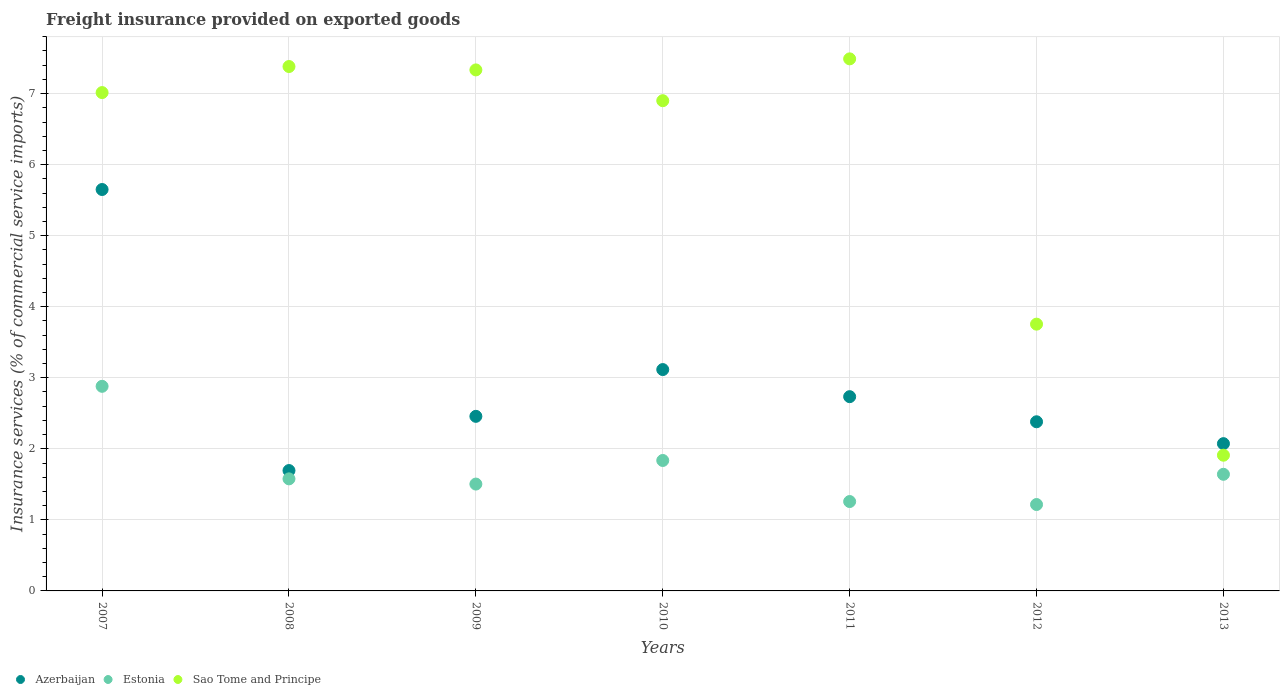How many different coloured dotlines are there?
Your answer should be compact. 3. What is the freight insurance provided on exported goods in Sao Tome and Principe in 2007?
Your answer should be compact. 7.01. Across all years, what is the maximum freight insurance provided on exported goods in Sao Tome and Principe?
Offer a terse response. 7.49. Across all years, what is the minimum freight insurance provided on exported goods in Azerbaijan?
Make the answer very short. 1.69. In which year was the freight insurance provided on exported goods in Azerbaijan maximum?
Provide a short and direct response. 2007. What is the total freight insurance provided on exported goods in Estonia in the graph?
Offer a very short reply. 11.91. What is the difference between the freight insurance provided on exported goods in Estonia in 2008 and that in 2011?
Provide a short and direct response. 0.32. What is the difference between the freight insurance provided on exported goods in Sao Tome and Principe in 2008 and the freight insurance provided on exported goods in Azerbaijan in 2007?
Keep it short and to the point. 1.73. What is the average freight insurance provided on exported goods in Azerbaijan per year?
Ensure brevity in your answer.  2.87. In the year 2011, what is the difference between the freight insurance provided on exported goods in Estonia and freight insurance provided on exported goods in Sao Tome and Principe?
Your response must be concise. -6.23. In how many years, is the freight insurance provided on exported goods in Azerbaijan greater than 6.4 %?
Provide a short and direct response. 0. What is the ratio of the freight insurance provided on exported goods in Azerbaijan in 2010 to that in 2013?
Provide a short and direct response. 1.5. Is the freight insurance provided on exported goods in Azerbaijan in 2011 less than that in 2012?
Offer a terse response. No. Is the difference between the freight insurance provided on exported goods in Estonia in 2008 and 2013 greater than the difference between the freight insurance provided on exported goods in Sao Tome and Principe in 2008 and 2013?
Provide a succinct answer. No. What is the difference between the highest and the second highest freight insurance provided on exported goods in Azerbaijan?
Offer a very short reply. 2.53. What is the difference between the highest and the lowest freight insurance provided on exported goods in Azerbaijan?
Make the answer very short. 3.96. Is the sum of the freight insurance provided on exported goods in Estonia in 2010 and 2013 greater than the maximum freight insurance provided on exported goods in Azerbaijan across all years?
Your response must be concise. No. Is it the case that in every year, the sum of the freight insurance provided on exported goods in Estonia and freight insurance provided on exported goods in Sao Tome and Principe  is greater than the freight insurance provided on exported goods in Azerbaijan?
Ensure brevity in your answer.  Yes. Is the freight insurance provided on exported goods in Azerbaijan strictly less than the freight insurance provided on exported goods in Estonia over the years?
Offer a terse response. No. How many dotlines are there?
Make the answer very short. 3. How many years are there in the graph?
Ensure brevity in your answer.  7. What is the difference between two consecutive major ticks on the Y-axis?
Offer a terse response. 1. Does the graph contain grids?
Make the answer very short. Yes. Where does the legend appear in the graph?
Keep it short and to the point. Bottom left. How many legend labels are there?
Offer a terse response. 3. What is the title of the graph?
Keep it short and to the point. Freight insurance provided on exported goods. What is the label or title of the X-axis?
Your answer should be very brief. Years. What is the label or title of the Y-axis?
Provide a short and direct response. Insurance services (% of commercial service imports). What is the Insurance services (% of commercial service imports) in Azerbaijan in 2007?
Offer a very short reply. 5.65. What is the Insurance services (% of commercial service imports) in Estonia in 2007?
Your answer should be compact. 2.88. What is the Insurance services (% of commercial service imports) of Sao Tome and Principe in 2007?
Provide a short and direct response. 7.01. What is the Insurance services (% of commercial service imports) of Azerbaijan in 2008?
Give a very brief answer. 1.69. What is the Insurance services (% of commercial service imports) of Estonia in 2008?
Provide a succinct answer. 1.58. What is the Insurance services (% of commercial service imports) of Sao Tome and Principe in 2008?
Your answer should be compact. 7.38. What is the Insurance services (% of commercial service imports) of Azerbaijan in 2009?
Give a very brief answer. 2.46. What is the Insurance services (% of commercial service imports) of Estonia in 2009?
Make the answer very short. 1.5. What is the Insurance services (% of commercial service imports) in Sao Tome and Principe in 2009?
Offer a very short reply. 7.33. What is the Insurance services (% of commercial service imports) of Azerbaijan in 2010?
Your response must be concise. 3.12. What is the Insurance services (% of commercial service imports) in Estonia in 2010?
Give a very brief answer. 1.84. What is the Insurance services (% of commercial service imports) in Sao Tome and Principe in 2010?
Your answer should be compact. 6.9. What is the Insurance services (% of commercial service imports) of Azerbaijan in 2011?
Provide a succinct answer. 2.73. What is the Insurance services (% of commercial service imports) of Estonia in 2011?
Provide a short and direct response. 1.26. What is the Insurance services (% of commercial service imports) of Sao Tome and Principe in 2011?
Make the answer very short. 7.49. What is the Insurance services (% of commercial service imports) of Azerbaijan in 2012?
Make the answer very short. 2.38. What is the Insurance services (% of commercial service imports) of Estonia in 2012?
Offer a terse response. 1.22. What is the Insurance services (% of commercial service imports) in Sao Tome and Principe in 2012?
Give a very brief answer. 3.75. What is the Insurance services (% of commercial service imports) of Azerbaijan in 2013?
Your answer should be compact. 2.07. What is the Insurance services (% of commercial service imports) of Estonia in 2013?
Ensure brevity in your answer.  1.64. What is the Insurance services (% of commercial service imports) in Sao Tome and Principe in 2013?
Give a very brief answer. 1.91. Across all years, what is the maximum Insurance services (% of commercial service imports) in Azerbaijan?
Give a very brief answer. 5.65. Across all years, what is the maximum Insurance services (% of commercial service imports) in Estonia?
Your response must be concise. 2.88. Across all years, what is the maximum Insurance services (% of commercial service imports) in Sao Tome and Principe?
Offer a very short reply. 7.49. Across all years, what is the minimum Insurance services (% of commercial service imports) in Azerbaijan?
Keep it short and to the point. 1.69. Across all years, what is the minimum Insurance services (% of commercial service imports) of Estonia?
Provide a succinct answer. 1.22. Across all years, what is the minimum Insurance services (% of commercial service imports) of Sao Tome and Principe?
Offer a very short reply. 1.91. What is the total Insurance services (% of commercial service imports) in Azerbaijan in the graph?
Ensure brevity in your answer.  20.11. What is the total Insurance services (% of commercial service imports) in Estonia in the graph?
Provide a short and direct response. 11.91. What is the total Insurance services (% of commercial service imports) in Sao Tome and Principe in the graph?
Offer a very short reply. 41.78. What is the difference between the Insurance services (% of commercial service imports) of Azerbaijan in 2007 and that in 2008?
Provide a succinct answer. 3.96. What is the difference between the Insurance services (% of commercial service imports) of Estonia in 2007 and that in 2008?
Ensure brevity in your answer.  1.3. What is the difference between the Insurance services (% of commercial service imports) of Sao Tome and Principe in 2007 and that in 2008?
Ensure brevity in your answer.  -0.37. What is the difference between the Insurance services (% of commercial service imports) of Azerbaijan in 2007 and that in 2009?
Keep it short and to the point. 3.19. What is the difference between the Insurance services (% of commercial service imports) in Estonia in 2007 and that in 2009?
Your response must be concise. 1.38. What is the difference between the Insurance services (% of commercial service imports) in Sao Tome and Principe in 2007 and that in 2009?
Ensure brevity in your answer.  -0.32. What is the difference between the Insurance services (% of commercial service imports) of Azerbaijan in 2007 and that in 2010?
Make the answer very short. 2.53. What is the difference between the Insurance services (% of commercial service imports) in Estonia in 2007 and that in 2010?
Your answer should be compact. 1.04. What is the difference between the Insurance services (% of commercial service imports) in Sao Tome and Principe in 2007 and that in 2010?
Your answer should be very brief. 0.11. What is the difference between the Insurance services (% of commercial service imports) in Azerbaijan in 2007 and that in 2011?
Keep it short and to the point. 2.92. What is the difference between the Insurance services (% of commercial service imports) in Estonia in 2007 and that in 2011?
Ensure brevity in your answer.  1.62. What is the difference between the Insurance services (% of commercial service imports) of Sao Tome and Principe in 2007 and that in 2011?
Your answer should be very brief. -0.47. What is the difference between the Insurance services (% of commercial service imports) in Azerbaijan in 2007 and that in 2012?
Your response must be concise. 3.27. What is the difference between the Insurance services (% of commercial service imports) in Estonia in 2007 and that in 2012?
Provide a succinct answer. 1.66. What is the difference between the Insurance services (% of commercial service imports) of Sao Tome and Principe in 2007 and that in 2012?
Make the answer very short. 3.26. What is the difference between the Insurance services (% of commercial service imports) of Azerbaijan in 2007 and that in 2013?
Provide a succinct answer. 3.58. What is the difference between the Insurance services (% of commercial service imports) in Estonia in 2007 and that in 2013?
Provide a succinct answer. 1.24. What is the difference between the Insurance services (% of commercial service imports) in Sao Tome and Principe in 2007 and that in 2013?
Offer a very short reply. 5.1. What is the difference between the Insurance services (% of commercial service imports) in Azerbaijan in 2008 and that in 2009?
Ensure brevity in your answer.  -0.76. What is the difference between the Insurance services (% of commercial service imports) of Estonia in 2008 and that in 2009?
Keep it short and to the point. 0.07. What is the difference between the Insurance services (% of commercial service imports) of Sao Tome and Principe in 2008 and that in 2009?
Your response must be concise. 0.05. What is the difference between the Insurance services (% of commercial service imports) in Azerbaijan in 2008 and that in 2010?
Offer a very short reply. -1.42. What is the difference between the Insurance services (% of commercial service imports) in Estonia in 2008 and that in 2010?
Provide a succinct answer. -0.26. What is the difference between the Insurance services (% of commercial service imports) of Sao Tome and Principe in 2008 and that in 2010?
Keep it short and to the point. 0.48. What is the difference between the Insurance services (% of commercial service imports) in Azerbaijan in 2008 and that in 2011?
Offer a terse response. -1.04. What is the difference between the Insurance services (% of commercial service imports) of Estonia in 2008 and that in 2011?
Offer a terse response. 0.32. What is the difference between the Insurance services (% of commercial service imports) of Sao Tome and Principe in 2008 and that in 2011?
Ensure brevity in your answer.  -0.11. What is the difference between the Insurance services (% of commercial service imports) of Azerbaijan in 2008 and that in 2012?
Provide a succinct answer. -0.69. What is the difference between the Insurance services (% of commercial service imports) of Estonia in 2008 and that in 2012?
Keep it short and to the point. 0.36. What is the difference between the Insurance services (% of commercial service imports) in Sao Tome and Principe in 2008 and that in 2012?
Give a very brief answer. 3.63. What is the difference between the Insurance services (% of commercial service imports) of Azerbaijan in 2008 and that in 2013?
Give a very brief answer. -0.38. What is the difference between the Insurance services (% of commercial service imports) in Estonia in 2008 and that in 2013?
Offer a very short reply. -0.06. What is the difference between the Insurance services (% of commercial service imports) in Sao Tome and Principe in 2008 and that in 2013?
Keep it short and to the point. 5.47. What is the difference between the Insurance services (% of commercial service imports) in Azerbaijan in 2009 and that in 2010?
Your answer should be very brief. -0.66. What is the difference between the Insurance services (% of commercial service imports) in Estonia in 2009 and that in 2010?
Your response must be concise. -0.33. What is the difference between the Insurance services (% of commercial service imports) of Sao Tome and Principe in 2009 and that in 2010?
Offer a terse response. 0.43. What is the difference between the Insurance services (% of commercial service imports) of Azerbaijan in 2009 and that in 2011?
Your answer should be compact. -0.28. What is the difference between the Insurance services (% of commercial service imports) of Estonia in 2009 and that in 2011?
Your answer should be compact. 0.25. What is the difference between the Insurance services (% of commercial service imports) of Sao Tome and Principe in 2009 and that in 2011?
Provide a succinct answer. -0.16. What is the difference between the Insurance services (% of commercial service imports) of Azerbaijan in 2009 and that in 2012?
Keep it short and to the point. 0.08. What is the difference between the Insurance services (% of commercial service imports) of Estonia in 2009 and that in 2012?
Offer a terse response. 0.29. What is the difference between the Insurance services (% of commercial service imports) of Sao Tome and Principe in 2009 and that in 2012?
Make the answer very short. 3.58. What is the difference between the Insurance services (% of commercial service imports) of Azerbaijan in 2009 and that in 2013?
Make the answer very short. 0.38. What is the difference between the Insurance services (% of commercial service imports) in Estonia in 2009 and that in 2013?
Offer a very short reply. -0.14. What is the difference between the Insurance services (% of commercial service imports) of Sao Tome and Principe in 2009 and that in 2013?
Make the answer very short. 5.42. What is the difference between the Insurance services (% of commercial service imports) of Azerbaijan in 2010 and that in 2011?
Your answer should be very brief. 0.38. What is the difference between the Insurance services (% of commercial service imports) of Estonia in 2010 and that in 2011?
Make the answer very short. 0.58. What is the difference between the Insurance services (% of commercial service imports) in Sao Tome and Principe in 2010 and that in 2011?
Ensure brevity in your answer.  -0.59. What is the difference between the Insurance services (% of commercial service imports) in Azerbaijan in 2010 and that in 2012?
Your response must be concise. 0.73. What is the difference between the Insurance services (% of commercial service imports) in Estonia in 2010 and that in 2012?
Your answer should be compact. 0.62. What is the difference between the Insurance services (% of commercial service imports) in Sao Tome and Principe in 2010 and that in 2012?
Provide a succinct answer. 3.15. What is the difference between the Insurance services (% of commercial service imports) of Azerbaijan in 2010 and that in 2013?
Your response must be concise. 1.04. What is the difference between the Insurance services (% of commercial service imports) of Estonia in 2010 and that in 2013?
Ensure brevity in your answer.  0.19. What is the difference between the Insurance services (% of commercial service imports) in Sao Tome and Principe in 2010 and that in 2013?
Your answer should be very brief. 4.99. What is the difference between the Insurance services (% of commercial service imports) in Azerbaijan in 2011 and that in 2012?
Provide a short and direct response. 0.35. What is the difference between the Insurance services (% of commercial service imports) of Estonia in 2011 and that in 2012?
Your answer should be very brief. 0.04. What is the difference between the Insurance services (% of commercial service imports) of Sao Tome and Principe in 2011 and that in 2012?
Offer a terse response. 3.73. What is the difference between the Insurance services (% of commercial service imports) of Azerbaijan in 2011 and that in 2013?
Ensure brevity in your answer.  0.66. What is the difference between the Insurance services (% of commercial service imports) in Estonia in 2011 and that in 2013?
Offer a very short reply. -0.38. What is the difference between the Insurance services (% of commercial service imports) of Sao Tome and Principe in 2011 and that in 2013?
Ensure brevity in your answer.  5.58. What is the difference between the Insurance services (% of commercial service imports) in Azerbaijan in 2012 and that in 2013?
Your response must be concise. 0.31. What is the difference between the Insurance services (% of commercial service imports) in Estonia in 2012 and that in 2013?
Give a very brief answer. -0.43. What is the difference between the Insurance services (% of commercial service imports) of Sao Tome and Principe in 2012 and that in 2013?
Offer a terse response. 1.84. What is the difference between the Insurance services (% of commercial service imports) of Azerbaijan in 2007 and the Insurance services (% of commercial service imports) of Estonia in 2008?
Offer a very short reply. 4.07. What is the difference between the Insurance services (% of commercial service imports) in Azerbaijan in 2007 and the Insurance services (% of commercial service imports) in Sao Tome and Principe in 2008?
Give a very brief answer. -1.73. What is the difference between the Insurance services (% of commercial service imports) in Estonia in 2007 and the Insurance services (% of commercial service imports) in Sao Tome and Principe in 2008?
Give a very brief answer. -4.5. What is the difference between the Insurance services (% of commercial service imports) in Azerbaijan in 2007 and the Insurance services (% of commercial service imports) in Estonia in 2009?
Your response must be concise. 4.15. What is the difference between the Insurance services (% of commercial service imports) of Azerbaijan in 2007 and the Insurance services (% of commercial service imports) of Sao Tome and Principe in 2009?
Your response must be concise. -1.68. What is the difference between the Insurance services (% of commercial service imports) in Estonia in 2007 and the Insurance services (% of commercial service imports) in Sao Tome and Principe in 2009?
Your answer should be very brief. -4.45. What is the difference between the Insurance services (% of commercial service imports) of Azerbaijan in 2007 and the Insurance services (% of commercial service imports) of Estonia in 2010?
Offer a terse response. 3.81. What is the difference between the Insurance services (% of commercial service imports) of Azerbaijan in 2007 and the Insurance services (% of commercial service imports) of Sao Tome and Principe in 2010?
Keep it short and to the point. -1.25. What is the difference between the Insurance services (% of commercial service imports) of Estonia in 2007 and the Insurance services (% of commercial service imports) of Sao Tome and Principe in 2010?
Provide a succinct answer. -4.02. What is the difference between the Insurance services (% of commercial service imports) in Azerbaijan in 2007 and the Insurance services (% of commercial service imports) in Estonia in 2011?
Offer a terse response. 4.39. What is the difference between the Insurance services (% of commercial service imports) of Azerbaijan in 2007 and the Insurance services (% of commercial service imports) of Sao Tome and Principe in 2011?
Make the answer very short. -1.84. What is the difference between the Insurance services (% of commercial service imports) in Estonia in 2007 and the Insurance services (% of commercial service imports) in Sao Tome and Principe in 2011?
Keep it short and to the point. -4.61. What is the difference between the Insurance services (% of commercial service imports) of Azerbaijan in 2007 and the Insurance services (% of commercial service imports) of Estonia in 2012?
Your answer should be very brief. 4.43. What is the difference between the Insurance services (% of commercial service imports) of Azerbaijan in 2007 and the Insurance services (% of commercial service imports) of Sao Tome and Principe in 2012?
Your answer should be compact. 1.9. What is the difference between the Insurance services (% of commercial service imports) of Estonia in 2007 and the Insurance services (% of commercial service imports) of Sao Tome and Principe in 2012?
Make the answer very short. -0.88. What is the difference between the Insurance services (% of commercial service imports) of Azerbaijan in 2007 and the Insurance services (% of commercial service imports) of Estonia in 2013?
Offer a terse response. 4.01. What is the difference between the Insurance services (% of commercial service imports) in Azerbaijan in 2007 and the Insurance services (% of commercial service imports) in Sao Tome and Principe in 2013?
Make the answer very short. 3.74. What is the difference between the Insurance services (% of commercial service imports) of Estonia in 2007 and the Insurance services (% of commercial service imports) of Sao Tome and Principe in 2013?
Your answer should be compact. 0.97. What is the difference between the Insurance services (% of commercial service imports) of Azerbaijan in 2008 and the Insurance services (% of commercial service imports) of Estonia in 2009?
Provide a short and direct response. 0.19. What is the difference between the Insurance services (% of commercial service imports) of Azerbaijan in 2008 and the Insurance services (% of commercial service imports) of Sao Tome and Principe in 2009?
Give a very brief answer. -5.64. What is the difference between the Insurance services (% of commercial service imports) of Estonia in 2008 and the Insurance services (% of commercial service imports) of Sao Tome and Principe in 2009?
Provide a short and direct response. -5.76. What is the difference between the Insurance services (% of commercial service imports) in Azerbaijan in 2008 and the Insurance services (% of commercial service imports) in Estonia in 2010?
Ensure brevity in your answer.  -0.14. What is the difference between the Insurance services (% of commercial service imports) in Azerbaijan in 2008 and the Insurance services (% of commercial service imports) in Sao Tome and Principe in 2010?
Give a very brief answer. -5.21. What is the difference between the Insurance services (% of commercial service imports) in Estonia in 2008 and the Insurance services (% of commercial service imports) in Sao Tome and Principe in 2010?
Offer a very short reply. -5.32. What is the difference between the Insurance services (% of commercial service imports) in Azerbaijan in 2008 and the Insurance services (% of commercial service imports) in Estonia in 2011?
Offer a very short reply. 0.44. What is the difference between the Insurance services (% of commercial service imports) of Azerbaijan in 2008 and the Insurance services (% of commercial service imports) of Sao Tome and Principe in 2011?
Offer a terse response. -5.79. What is the difference between the Insurance services (% of commercial service imports) of Estonia in 2008 and the Insurance services (% of commercial service imports) of Sao Tome and Principe in 2011?
Give a very brief answer. -5.91. What is the difference between the Insurance services (% of commercial service imports) in Azerbaijan in 2008 and the Insurance services (% of commercial service imports) in Estonia in 2012?
Your answer should be compact. 0.48. What is the difference between the Insurance services (% of commercial service imports) of Azerbaijan in 2008 and the Insurance services (% of commercial service imports) of Sao Tome and Principe in 2012?
Your response must be concise. -2.06. What is the difference between the Insurance services (% of commercial service imports) of Estonia in 2008 and the Insurance services (% of commercial service imports) of Sao Tome and Principe in 2012?
Offer a terse response. -2.18. What is the difference between the Insurance services (% of commercial service imports) in Azerbaijan in 2008 and the Insurance services (% of commercial service imports) in Estonia in 2013?
Ensure brevity in your answer.  0.05. What is the difference between the Insurance services (% of commercial service imports) of Azerbaijan in 2008 and the Insurance services (% of commercial service imports) of Sao Tome and Principe in 2013?
Give a very brief answer. -0.22. What is the difference between the Insurance services (% of commercial service imports) of Estonia in 2008 and the Insurance services (% of commercial service imports) of Sao Tome and Principe in 2013?
Offer a very short reply. -0.33. What is the difference between the Insurance services (% of commercial service imports) of Azerbaijan in 2009 and the Insurance services (% of commercial service imports) of Estonia in 2010?
Provide a succinct answer. 0.62. What is the difference between the Insurance services (% of commercial service imports) of Azerbaijan in 2009 and the Insurance services (% of commercial service imports) of Sao Tome and Principe in 2010?
Your response must be concise. -4.44. What is the difference between the Insurance services (% of commercial service imports) of Estonia in 2009 and the Insurance services (% of commercial service imports) of Sao Tome and Principe in 2010?
Make the answer very short. -5.4. What is the difference between the Insurance services (% of commercial service imports) in Azerbaijan in 2009 and the Insurance services (% of commercial service imports) in Estonia in 2011?
Ensure brevity in your answer.  1.2. What is the difference between the Insurance services (% of commercial service imports) in Azerbaijan in 2009 and the Insurance services (% of commercial service imports) in Sao Tome and Principe in 2011?
Ensure brevity in your answer.  -5.03. What is the difference between the Insurance services (% of commercial service imports) of Estonia in 2009 and the Insurance services (% of commercial service imports) of Sao Tome and Principe in 2011?
Offer a terse response. -5.99. What is the difference between the Insurance services (% of commercial service imports) of Azerbaijan in 2009 and the Insurance services (% of commercial service imports) of Estonia in 2012?
Your response must be concise. 1.24. What is the difference between the Insurance services (% of commercial service imports) in Azerbaijan in 2009 and the Insurance services (% of commercial service imports) in Sao Tome and Principe in 2012?
Give a very brief answer. -1.3. What is the difference between the Insurance services (% of commercial service imports) of Estonia in 2009 and the Insurance services (% of commercial service imports) of Sao Tome and Principe in 2012?
Ensure brevity in your answer.  -2.25. What is the difference between the Insurance services (% of commercial service imports) in Azerbaijan in 2009 and the Insurance services (% of commercial service imports) in Estonia in 2013?
Provide a short and direct response. 0.82. What is the difference between the Insurance services (% of commercial service imports) of Azerbaijan in 2009 and the Insurance services (% of commercial service imports) of Sao Tome and Principe in 2013?
Your answer should be very brief. 0.55. What is the difference between the Insurance services (% of commercial service imports) in Estonia in 2009 and the Insurance services (% of commercial service imports) in Sao Tome and Principe in 2013?
Give a very brief answer. -0.41. What is the difference between the Insurance services (% of commercial service imports) of Azerbaijan in 2010 and the Insurance services (% of commercial service imports) of Estonia in 2011?
Provide a succinct answer. 1.86. What is the difference between the Insurance services (% of commercial service imports) of Azerbaijan in 2010 and the Insurance services (% of commercial service imports) of Sao Tome and Principe in 2011?
Give a very brief answer. -4.37. What is the difference between the Insurance services (% of commercial service imports) in Estonia in 2010 and the Insurance services (% of commercial service imports) in Sao Tome and Principe in 2011?
Provide a short and direct response. -5.65. What is the difference between the Insurance services (% of commercial service imports) of Azerbaijan in 2010 and the Insurance services (% of commercial service imports) of Estonia in 2012?
Your answer should be very brief. 1.9. What is the difference between the Insurance services (% of commercial service imports) of Azerbaijan in 2010 and the Insurance services (% of commercial service imports) of Sao Tome and Principe in 2012?
Make the answer very short. -0.64. What is the difference between the Insurance services (% of commercial service imports) in Estonia in 2010 and the Insurance services (% of commercial service imports) in Sao Tome and Principe in 2012?
Provide a short and direct response. -1.92. What is the difference between the Insurance services (% of commercial service imports) of Azerbaijan in 2010 and the Insurance services (% of commercial service imports) of Estonia in 2013?
Offer a terse response. 1.47. What is the difference between the Insurance services (% of commercial service imports) in Azerbaijan in 2010 and the Insurance services (% of commercial service imports) in Sao Tome and Principe in 2013?
Offer a very short reply. 1.21. What is the difference between the Insurance services (% of commercial service imports) of Estonia in 2010 and the Insurance services (% of commercial service imports) of Sao Tome and Principe in 2013?
Give a very brief answer. -0.07. What is the difference between the Insurance services (% of commercial service imports) of Azerbaijan in 2011 and the Insurance services (% of commercial service imports) of Estonia in 2012?
Give a very brief answer. 1.52. What is the difference between the Insurance services (% of commercial service imports) of Azerbaijan in 2011 and the Insurance services (% of commercial service imports) of Sao Tome and Principe in 2012?
Your response must be concise. -1.02. What is the difference between the Insurance services (% of commercial service imports) of Estonia in 2011 and the Insurance services (% of commercial service imports) of Sao Tome and Principe in 2012?
Your response must be concise. -2.5. What is the difference between the Insurance services (% of commercial service imports) of Azerbaijan in 2011 and the Insurance services (% of commercial service imports) of Estonia in 2013?
Your answer should be very brief. 1.09. What is the difference between the Insurance services (% of commercial service imports) in Azerbaijan in 2011 and the Insurance services (% of commercial service imports) in Sao Tome and Principe in 2013?
Your response must be concise. 0.82. What is the difference between the Insurance services (% of commercial service imports) of Estonia in 2011 and the Insurance services (% of commercial service imports) of Sao Tome and Principe in 2013?
Keep it short and to the point. -0.65. What is the difference between the Insurance services (% of commercial service imports) in Azerbaijan in 2012 and the Insurance services (% of commercial service imports) in Estonia in 2013?
Provide a short and direct response. 0.74. What is the difference between the Insurance services (% of commercial service imports) in Azerbaijan in 2012 and the Insurance services (% of commercial service imports) in Sao Tome and Principe in 2013?
Your answer should be very brief. 0.47. What is the difference between the Insurance services (% of commercial service imports) of Estonia in 2012 and the Insurance services (% of commercial service imports) of Sao Tome and Principe in 2013?
Give a very brief answer. -0.69. What is the average Insurance services (% of commercial service imports) in Azerbaijan per year?
Ensure brevity in your answer.  2.87. What is the average Insurance services (% of commercial service imports) in Estonia per year?
Your answer should be compact. 1.7. What is the average Insurance services (% of commercial service imports) of Sao Tome and Principe per year?
Give a very brief answer. 5.97. In the year 2007, what is the difference between the Insurance services (% of commercial service imports) in Azerbaijan and Insurance services (% of commercial service imports) in Estonia?
Offer a very short reply. 2.77. In the year 2007, what is the difference between the Insurance services (% of commercial service imports) of Azerbaijan and Insurance services (% of commercial service imports) of Sao Tome and Principe?
Offer a terse response. -1.36. In the year 2007, what is the difference between the Insurance services (% of commercial service imports) in Estonia and Insurance services (% of commercial service imports) in Sao Tome and Principe?
Offer a terse response. -4.13. In the year 2008, what is the difference between the Insurance services (% of commercial service imports) in Azerbaijan and Insurance services (% of commercial service imports) in Estonia?
Provide a short and direct response. 0.12. In the year 2008, what is the difference between the Insurance services (% of commercial service imports) in Azerbaijan and Insurance services (% of commercial service imports) in Sao Tome and Principe?
Your response must be concise. -5.69. In the year 2008, what is the difference between the Insurance services (% of commercial service imports) of Estonia and Insurance services (% of commercial service imports) of Sao Tome and Principe?
Keep it short and to the point. -5.8. In the year 2009, what is the difference between the Insurance services (% of commercial service imports) of Azerbaijan and Insurance services (% of commercial service imports) of Estonia?
Ensure brevity in your answer.  0.95. In the year 2009, what is the difference between the Insurance services (% of commercial service imports) of Azerbaijan and Insurance services (% of commercial service imports) of Sao Tome and Principe?
Your response must be concise. -4.88. In the year 2009, what is the difference between the Insurance services (% of commercial service imports) of Estonia and Insurance services (% of commercial service imports) of Sao Tome and Principe?
Offer a very short reply. -5.83. In the year 2010, what is the difference between the Insurance services (% of commercial service imports) in Azerbaijan and Insurance services (% of commercial service imports) in Estonia?
Ensure brevity in your answer.  1.28. In the year 2010, what is the difference between the Insurance services (% of commercial service imports) in Azerbaijan and Insurance services (% of commercial service imports) in Sao Tome and Principe?
Make the answer very short. -3.78. In the year 2010, what is the difference between the Insurance services (% of commercial service imports) in Estonia and Insurance services (% of commercial service imports) in Sao Tome and Principe?
Provide a succinct answer. -5.06. In the year 2011, what is the difference between the Insurance services (% of commercial service imports) of Azerbaijan and Insurance services (% of commercial service imports) of Estonia?
Offer a terse response. 1.48. In the year 2011, what is the difference between the Insurance services (% of commercial service imports) of Azerbaijan and Insurance services (% of commercial service imports) of Sao Tome and Principe?
Provide a short and direct response. -4.75. In the year 2011, what is the difference between the Insurance services (% of commercial service imports) of Estonia and Insurance services (% of commercial service imports) of Sao Tome and Principe?
Your response must be concise. -6.23. In the year 2012, what is the difference between the Insurance services (% of commercial service imports) of Azerbaijan and Insurance services (% of commercial service imports) of Estonia?
Your answer should be compact. 1.16. In the year 2012, what is the difference between the Insurance services (% of commercial service imports) in Azerbaijan and Insurance services (% of commercial service imports) in Sao Tome and Principe?
Ensure brevity in your answer.  -1.37. In the year 2012, what is the difference between the Insurance services (% of commercial service imports) of Estonia and Insurance services (% of commercial service imports) of Sao Tome and Principe?
Offer a very short reply. -2.54. In the year 2013, what is the difference between the Insurance services (% of commercial service imports) in Azerbaijan and Insurance services (% of commercial service imports) in Estonia?
Your answer should be very brief. 0.43. In the year 2013, what is the difference between the Insurance services (% of commercial service imports) in Azerbaijan and Insurance services (% of commercial service imports) in Sao Tome and Principe?
Your answer should be very brief. 0.16. In the year 2013, what is the difference between the Insurance services (% of commercial service imports) in Estonia and Insurance services (% of commercial service imports) in Sao Tome and Principe?
Offer a terse response. -0.27. What is the ratio of the Insurance services (% of commercial service imports) of Azerbaijan in 2007 to that in 2008?
Make the answer very short. 3.33. What is the ratio of the Insurance services (% of commercial service imports) of Estonia in 2007 to that in 2008?
Provide a short and direct response. 1.83. What is the ratio of the Insurance services (% of commercial service imports) in Sao Tome and Principe in 2007 to that in 2008?
Offer a very short reply. 0.95. What is the ratio of the Insurance services (% of commercial service imports) in Azerbaijan in 2007 to that in 2009?
Provide a short and direct response. 2.3. What is the ratio of the Insurance services (% of commercial service imports) in Estonia in 2007 to that in 2009?
Provide a short and direct response. 1.91. What is the ratio of the Insurance services (% of commercial service imports) of Sao Tome and Principe in 2007 to that in 2009?
Provide a succinct answer. 0.96. What is the ratio of the Insurance services (% of commercial service imports) in Azerbaijan in 2007 to that in 2010?
Your answer should be compact. 1.81. What is the ratio of the Insurance services (% of commercial service imports) in Estonia in 2007 to that in 2010?
Your answer should be compact. 1.57. What is the ratio of the Insurance services (% of commercial service imports) in Sao Tome and Principe in 2007 to that in 2010?
Ensure brevity in your answer.  1.02. What is the ratio of the Insurance services (% of commercial service imports) of Azerbaijan in 2007 to that in 2011?
Make the answer very short. 2.07. What is the ratio of the Insurance services (% of commercial service imports) in Estonia in 2007 to that in 2011?
Offer a terse response. 2.29. What is the ratio of the Insurance services (% of commercial service imports) of Sao Tome and Principe in 2007 to that in 2011?
Make the answer very short. 0.94. What is the ratio of the Insurance services (% of commercial service imports) in Azerbaijan in 2007 to that in 2012?
Give a very brief answer. 2.37. What is the ratio of the Insurance services (% of commercial service imports) in Estonia in 2007 to that in 2012?
Your response must be concise. 2.37. What is the ratio of the Insurance services (% of commercial service imports) of Sao Tome and Principe in 2007 to that in 2012?
Provide a short and direct response. 1.87. What is the ratio of the Insurance services (% of commercial service imports) in Azerbaijan in 2007 to that in 2013?
Ensure brevity in your answer.  2.73. What is the ratio of the Insurance services (% of commercial service imports) in Estonia in 2007 to that in 2013?
Your answer should be compact. 1.75. What is the ratio of the Insurance services (% of commercial service imports) in Sao Tome and Principe in 2007 to that in 2013?
Give a very brief answer. 3.67. What is the ratio of the Insurance services (% of commercial service imports) of Azerbaijan in 2008 to that in 2009?
Offer a very short reply. 0.69. What is the ratio of the Insurance services (% of commercial service imports) of Estonia in 2008 to that in 2009?
Give a very brief answer. 1.05. What is the ratio of the Insurance services (% of commercial service imports) of Azerbaijan in 2008 to that in 2010?
Your response must be concise. 0.54. What is the ratio of the Insurance services (% of commercial service imports) of Estonia in 2008 to that in 2010?
Provide a succinct answer. 0.86. What is the ratio of the Insurance services (% of commercial service imports) of Sao Tome and Principe in 2008 to that in 2010?
Offer a very short reply. 1.07. What is the ratio of the Insurance services (% of commercial service imports) in Azerbaijan in 2008 to that in 2011?
Keep it short and to the point. 0.62. What is the ratio of the Insurance services (% of commercial service imports) in Estonia in 2008 to that in 2011?
Keep it short and to the point. 1.25. What is the ratio of the Insurance services (% of commercial service imports) in Sao Tome and Principe in 2008 to that in 2011?
Ensure brevity in your answer.  0.99. What is the ratio of the Insurance services (% of commercial service imports) in Azerbaijan in 2008 to that in 2012?
Keep it short and to the point. 0.71. What is the ratio of the Insurance services (% of commercial service imports) in Estonia in 2008 to that in 2012?
Give a very brief answer. 1.3. What is the ratio of the Insurance services (% of commercial service imports) of Sao Tome and Principe in 2008 to that in 2012?
Provide a short and direct response. 1.97. What is the ratio of the Insurance services (% of commercial service imports) in Azerbaijan in 2008 to that in 2013?
Your response must be concise. 0.82. What is the ratio of the Insurance services (% of commercial service imports) of Estonia in 2008 to that in 2013?
Give a very brief answer. 0.96. What is the ratio of the Insurance services (% of commercial service imports) of Sao Tome and Principe in 2008 to that in 2013?
Provide a short and direct response. 3.86. What is the ratio of the Insurance services (% of commercial service imports) in Azerbaijan in 2009 to that in 2010?
Make the answer very short. 0.79. What is the ratio of the Insurance services (% of commercial service imports) in Estonia in 2009 to that in 2010?
Make the answer very short. 0.82. What is the ratio of the Insurance services (% of commercial service imports) of Sao Tome and Principe in 2009 to that in 2010?
Provide a succinct answer. 1.06. What is the ratio of the Insurance services (% of commercial service imports) in Azerbaijan in 2009 to that in 2011?
Ensure brevity in your answer.  0.9. What is the ratio of the Insurance services (% of commercial service imports) in Estonia in 2009 to that in 2011?
Your response must be concise. 1.2. What is the ratio of the Insurance services (% of commercial service imports) in Sao Tome and Principe in 2009 to that in 2011?
Your answer should be compact. 0.98. What is the ratio of the Insurance services (% of commercial service imports) of Azerbaijan in 2009 to that in 2012?
Provide a short and direct response. 1.03. What is the ratio of the Insurance services (% of commercial service imports) of Estonia in 2009 to that in 2012?
Your answer should be very brief. 1.24. What is the ratio of the Insurance services (% of commercial service imports) in Sao Tome and Principe in 2009 to that in 2012?
Offer a very short reply. 1.95. What is the ratio of the Insurance services (% of commercial service imports) in Azerbaijan in 2009 to that in 2013?
Keep it short and to the point. 1.19. What is the ratio of the Insurance services (% of commercial service imports) in Estonia in 2009 to that in 2013?
Offer a terse response. 0.92. What is the ratio of the Insurance services (% of commercial service imports) in Sao Tome and Principe in 2009 to that in 2013?
Provide a short and direct response. 3.84. What is the ratio of the Insurance services (% of commercial service imports) in Azerbaijan in 2010 to that in 2011?
Provide a succinct answer. 1.14. What is the ratio of the Insurance services (% of commercial service imports) in Estonia in 2010 to that in 2011?
Your response must be concise. 1.46. What is the ratio of the Insurance services (% of commercial service imports) in Sao Tome and Principe in 2010 to that in 2011?
Make the answer very short. 0.92. What is the ratio of the Insurance services (% of commercial service imports) in Azerbaijan in 2010 to that in 2012?
Provide a succinct answer. 1.31. What is the ratio of the Insurance services (% of commercial service imports) in Estonia in 2010 to that in 2012?
Offer a very short reply. 1.51. What is the ratio of the Insurance services (% of commercial service imports) of Sao Tome and Principe in 2010 to that in 2012?
Ensure brevity in your answer.  1.84. What is the ratio of the Insurance services (% of commercial service imports) in Azerbaijan in 2010 to that in 2013?
Your answer should be compact. 1.5. What is the ratio of the Insurance services (% of commercial service imports) in Estonia in 2010 to that in 2013?
Give a very brief answer. 1.12. What is the ratio of the Insurance services (% of commercial service imports) in Sao Tome and Principe in 2010 to that in 2013?
Give a very brief answer. 3.61. What is the ratio of the Insurance services (% of commercial service imports) in Azerbaijan in 2011 to that in 2012?
Ensure brevity in your answer.  1.15. What is the ratio of the Insurance services (% of commercial service imports) of Estonia in 2011 to that in 2012?
Provide a short and direct response. 1.03. What is the ratio of the Insurance services (% of commercial service imports) in Sao Tome and Principe in 2011 to that in 2012?
Give a very brief answer. 1.99. What is the ratio of the Insurance services (% of commercial service imports) in Azerbaijan in 2011 to that in 2013?
Give a very brief answer. 1.32. What is the ratio of the Insurance services (% of commercial service imports) of Estonia in 2011 to that in 2013?
Make the answer very short. 0.77. What is the ratio of the Insurance services (% of commercial service imports) in Sao Tome and Principe in 2011 to that in 2013?
Provide a succinct answer. 3.92. What is the ratio of the Insurance services (% of commercial service imports) in Azerbaijan in 2012 to that in 2013?
Provide a succinct answer. 1.15. What is the ratio of the Insurance services (% of commercial service imports) of Estonia in 2012 to that in 2013?
Offer a terse response. 0.74. What is the ratio of the Insurance services (% of commercial service imports) of Sao Tome and Principe in 2012 to that in 2013?
Ensure brevity in your answer.  1.97. What is the difference between the highest and the second highest Insurance services (% of commercial service imports) of Azerbaijan?
Your answer should be very brief. 2.53. What is the difference between the highest and the second highest Insurance services (% of commercial service imports) of Estonia?
Ensure brevity in your answer.  1.04. What is the difference between the highest and the second highest Insurance services (% of commercial service imports) in Sao Tome and Principe?
Make the answer very short. 0.11. What is the difference between the highest and the lowest Insurance services (% of commercial service imports) in Azerbaijan?
Give a very brief answer. 3.96. What is the difference between the highest and the lowest Insurance services (% of commercial service imports) of Estonia?
Your answer should be compact. 1.66. What is the difference between the highest and the lowest Insurance services (% of commercial service imports) in Sao Tome and Principe?
Ensure brevity in your answer.  5.58. 